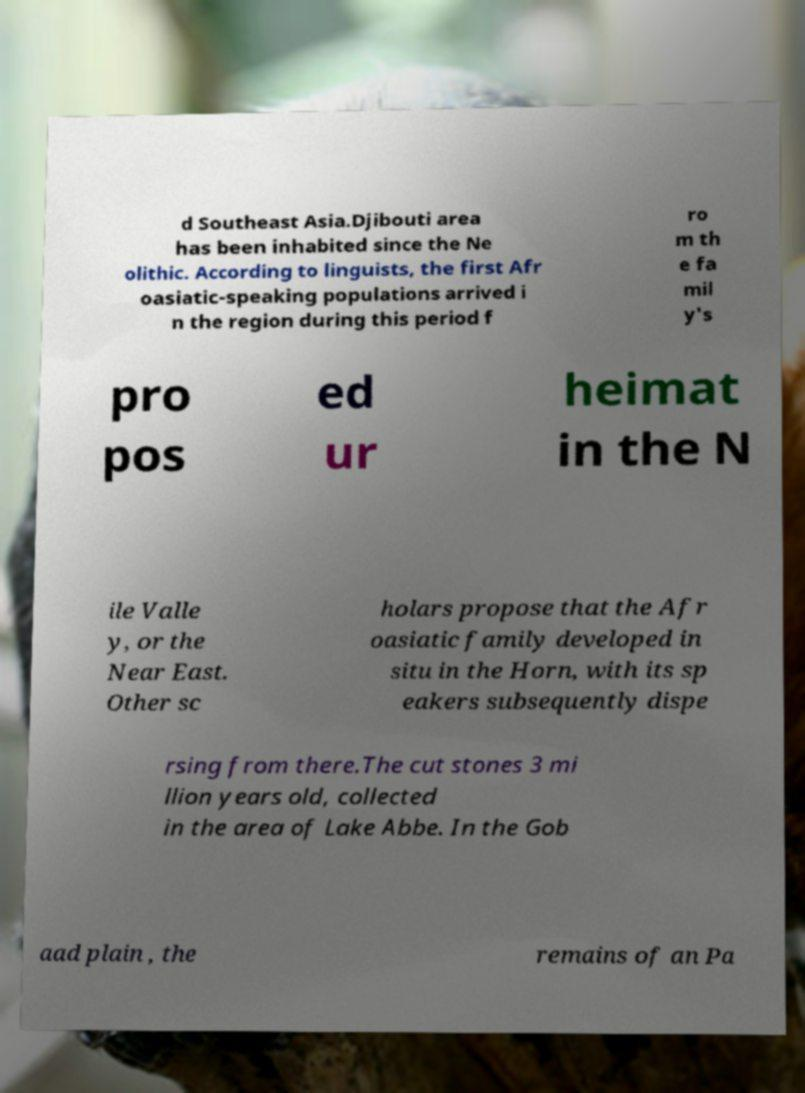Can you accurately transcribe the text from the provided image for me? d Southeast Asia.Djibouti area has been inhabited since the Ne olithic. According to linguists, the first Afr oasiatic-speaking populations arrived i n the region during this period f ro m th e fa mil y's pro pos ed ur heimat in the N ile Valle y, or the Near East. Other sc holars propose that the Afr oasiatic family developed in situ in the Horn, with its sp eakers subsequently dispe rsing from there.The cut stones 3 mi llion years old, collected in the area of Lake Abbe. In the Gob aad plain , the remains of an Pa 